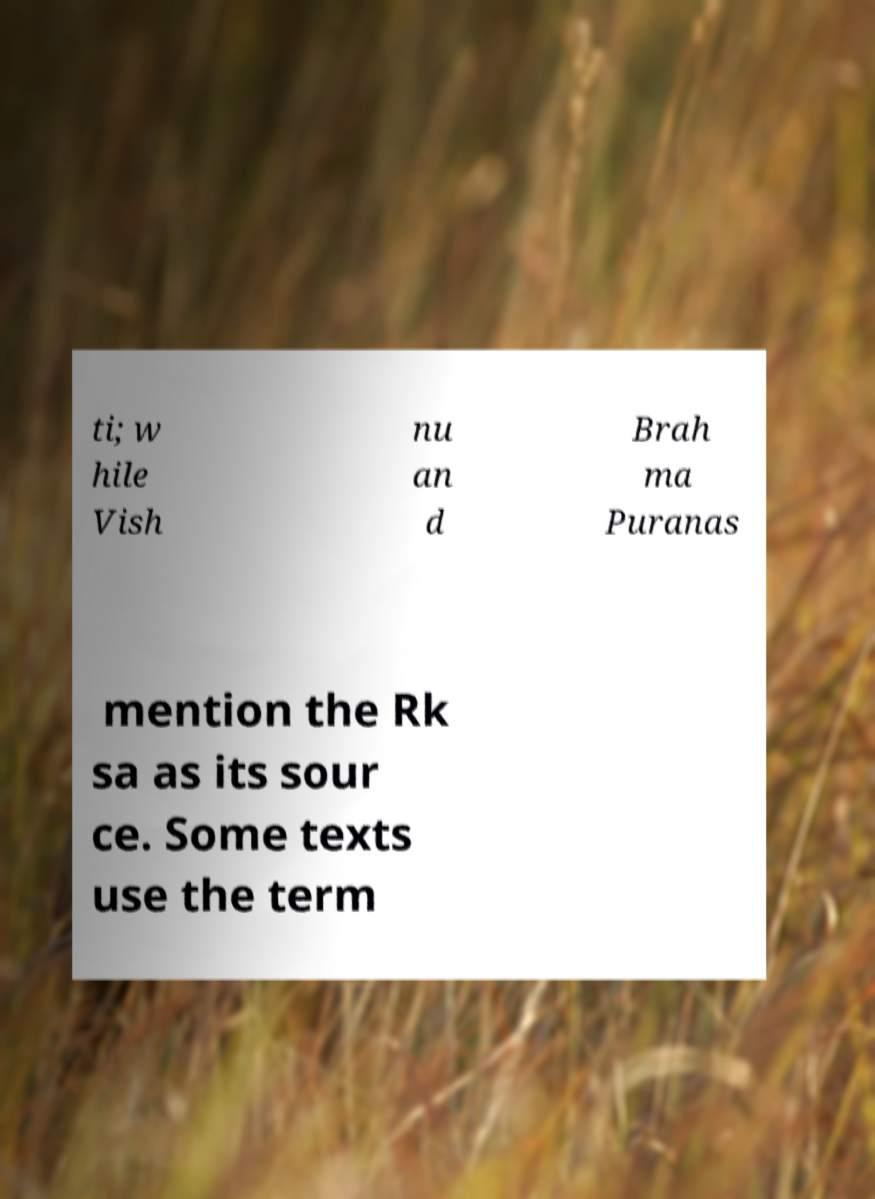Please identify and transcribe the text found in this image. ti; w hile Vish nu an d Brah ma Puranas mention the Rk sa as its sour ce. Some texts use the term 